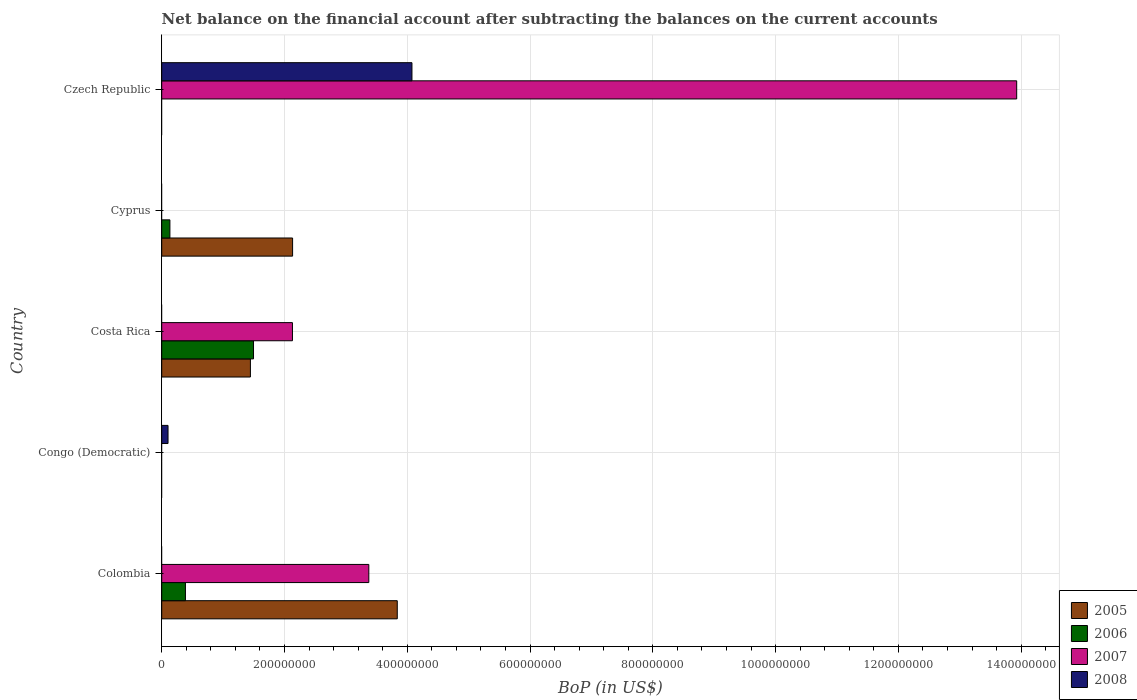Are the number of bars on each tick of the Y-axis equal?
Give a very brief answer. No. How many bars are there on the 5th tick from the top?
Provide a short and direct response. 3. How many bars are there on the 2nd tick from the bottom?
Make the answer very short. 1. In how many cases, is the number of bars for a given country not equal to the number of legend labels?
Ensure brevity in your answer.  5. Across all countries, what is the maximum Balance of Payments in 2006?
Your answer should be compact. 1.50e+08. What is the total Balance of Payments in 2007 in the graph?
Make the answer very short. 1.94e+09. What is the average Balance of Payments in 2006 per country?
Ensure brevity in your answer.  4.03e+07. What is the difference between the Balance of Payments in 2005 and Balance of Payments in 2006 in Cyprus?
Your answer should be very brief. 2.00e+08. What is the ratio of the Balance of Payments in 2005 in Costa Rica to that in Cyprus?
Keep it short and to the point. 0.68. What is the difference between the highest and the second highest Balance of Payments in 2006?
Keep it short and to the point. 1.11e+08. What is the difference between the highest and the lowest Balance of Payments in 2006?
Give a very brief answer. 1.50e+08. Is it the case that in every country, the sum of the Balance of Payments in 2008 and Balance of Payments in 2006 is greater than the sum of Balance of Payments in 2007 and Balance of Payments in 2005?
Give a very brief answer. No. Is it the case that in every country, the sum of the Balance of Payments in 2008 and Balance of Payments in 2005 is greater than the Balance of Payments in 2007?
Offer a very short reply. No. How many countries are there in the graph?
Make the answer very short. 5. What is the difference between two consecutive major ticks on the X-axis?
Make the answer very short. 2.00e+08. Does the graph contain grids?
Your answer should be compact. Yes. How many legend labels are there?
Provide a short and direct response. 4. What is the title of the graph?
Give a very brief answer. Net balance on the financial account after subtracting the balances on the current accounts. Does "1987" appear as one of the legend labels in the graph?
Your response must be concise. No. What is the label or title of the X-axis?
Make the answer very short. BoP (in US$). What is the BoP (in US$) in 2005 in Colombia?
Keep it short and to the point. 3.84e+08. What is the BoP (in US$) of 2006 in Colombia?
Your answer should be very brief. 3.87e+07. What is the BoP (in US$) of 2007 in Colombia?
Your answer should be compact. 3.37e+08. What is the BoP (in US$) of 2006 in Congo (Democratic)?
Provide a short and direct response. 0. What is the BoP (in US$) in 2007 in Congo (Democratic)?
Offer a very short reply. 0. What is the BoP (in US$) in 2008 in Congo (Democratic)?
Your answer should be compact. 1.03e+07. What is the BoP (in US$) of 2005 in Costa Rica?
Provide a short and direct response. 1.44e+08. What is the BoP (in US$) of 2006 in Costa Rica?
Provide a short and direct response. 1.50e+08. What is the BoP (in US$) of 2007 in Costa Rica?
Your answer should be compact. 2.13e+08. What is the BoP (in US$) of 2005 in Cyprus?
Provide a succinct answer. 2.13e+08. What is the BoP (in US$) in 2006 in Cyprus?
Your answer should be compact. 1.33e+07. What is the BoP (in US$) of 2007 in Cyprus?
Give a very brief answer. 0. What is the BoP (in US$) in 2006 in Czech Republic?
Your response must be concise. 0. What is the BoP (in US$) of 2007 in Czech Republic?
Keep it short and to the point. 1.39e+09. What is the BoP (in US$) of 2008 in Czech Republic?
Provide a short and direct response. 4.08e+08. Across all countries, what is the maximum BoP (in US$) of 2005?
Your answer should be compact. 3.84e+08. Across all countries, what is the maximum BoP (in US$) of 2006?
Keep it short and to the point. 1.50e+08. Across all countries, what is the maximum BoP (in US$) of 2007?
Offer a very short reply. 1.39e+09. Across all countries, what is the maximum BoP (in US$) of 2008?
Keep it short and to the point. 4.08e+08. Across all countries, what is the minimum BoP (in US$) of 2006?
Offer a terse response. 0. Across all countries, what is the minimum BoP (in US$) of 2008?
Offer a very short reply. 0. What is the total BoP (in US$) in 2005 in the graph?
Give a very brief answer. 7.41e+08. What is the total BoP (in US$) of 2006 in the graph?
Your answer should be very brief. 2.02e+08. What is the total BoP (in US$) of 2007 in the graph?
Give a very brief answer. 1.94e+09. What is the total BoP (in US$) in 2008 in the graph?
Make the answer very short. 4.18e+08. What is the difference between the BoP (in US$) in 2005 in Colombia and that in Costa Rica?
Provide a short and direct response. 2.39e+08. What is the difference between the BoP (in US$) of 2006 in Colombia and that in Costa Rica?
Your answer should be very brief. -1.11e+08. What is the difference between the BoP (in US$) of 2007 in Colombia and that in Costa Rica?
Your response must be concise. 1.24e+08. What is the difference between the BoP (in US$) of 2005 in Colombia and that in Cyprus?
Offer a very short reply. 1.70e+08. What is the difference between the BoP (in US$) in 2006 in Colombia and that in Cyprus?
Your response must be concise. 2.53e+07. What is the difference between the BoP (in US$) of 2007 in Colombia and that in Czech Republic?
Offer a terse response. -1.06e+09. What is the difference between the BoP (in US$) in 2008 in Congo (Democratic) and that in Czech Republic?
Provide a short and direct response. -3.97e+08. What is the difference between the BoP (in US$) of 2005 in Costa Rica and that in Cyprus?
Provide a succinct answer. -6.87e+07. What is the difference between the BoP (in US$) of 2006 in Costa Rica and that in Cyprus?
Provide a short and direct response. 1.36e+08. What is the difference between the BoP (in US$) of 2007 in Costa Rica and that in Czech Republic?
Provide a short and direct response. -1.18e+09. What is the difference between the BoP (in US$) in 2005 in Colombia and the BoP (in US$) in 2008 in Congo (Democratic)?
Your answer should be very brief. 3.73e+08. What is the difference between the BoP (in US$) of 2006 in Colombia and the BoP (in US$) of 2008 in Congo (Democratic)?
Offer a terse response. 2.84e+07. What is the difference between the BoP (in US$) of 2007 in Colombia and the BoP (in US$) of 2008 in Congo (Democratic)?
Offer a terse response. 3.27e+08. What is the difference between the BoP (in US$) of 2005 in Colombia and the BoP (in US$) of 2006 in Costa Rica?
Provide a succinct answer. 2.34e+08. What is the difference between the BoP (in US$) in 2005 in Colombia and the BoP (in US$) in 2007 in Costa Rica?
Give a very brief answer. 1.71e+08. What is the difference between the BoP (in US$) in 2006 in Colombia and the BoP (in US$) in 2007 in Costa Rica?
Make the answer very short. -1.74e+08. What is the difference between the BoP (in US$) of 2005 in Colombia and the BoP (in US$) of 2006 in Cyprus?
Keep it short and to the point. 3.70e+08. What is the difference between the BoP (in US$) of 2005 in Colombia and the BoP (in US$) of 2007 in Czech Republic?
Give a very brief answer. -1.01e+09. What is the difference between the BoP (in US$) in 2005 in Colombia and the BoP (in US$) in 2008 in Czech Republic?
Offer a terse response. -2.39e+07. What is the difference between the BoP (in US$) of 2006 in Colombia and the BoP (in US$) of 2007 in Czech Republic?
Give a very brief answer. -1.35e+09. What is the difference between the BoP (in US$) of 2006 in Colombia and the BoP (in US$) of 2008 in Czech Republic?
Provide a succinct answer. -3.69e+08. What is the difference between the BoP (in US$) of 2007 in Colombia and the BoP (in US$) of 2008 in Czech Republic?
Provide a short and direct response. -7.03e+07. What is the difference between the BoP (in US$) of 2005 in Costa Rica and the BoP (in US$) of 2006 in Cyprus?
Keep it short and to the point. 1.31e+08. What is the difference between the BoP (in US$) of 2005 in Costa Rica and the BoP (in US$) of 2007 in Czech Republic?
Offer a terse response. -1.25e+09. What is the difference between the BoP (in US$) in 2005 in Costa Rica and the BoP (in US$) in 2008 in Czech Republic?
Your response must be concise. -2.63e+08. What is the difference between the BoP (in US$) of 2006 in Costa Rica and the BoP (in US$) of 2007 in Czech Republic?
Your answer should be very brief. -1.24e+09. What is the difference between the BoP (in US$) in 2006 in Costa Rica and the BoP (in US$) in 2008 in Czech Republic?
Offer a terse response. -2.58e+08. What is the difference between the BoP (in US$) of 2007 in Costa Rica and the BoP (in US$) of 2008 in Czech Republic?
Provide a short and direct response. -1.95e+08. What is the difference between the BoP (in US$) of 2005 in Cyprus and the BoP (in US$) of 2007 in Czech Republic?
Offer a terse response. -1.18e+09. What is the difference between the BoP (in US$) in 2005 in Cyprus and the BoP (in US$) in 2008 in Czech Republic?
Ensure brevity in your answer.  -1.94e+08. What is the difference between the BoP (in US$) of 2006 in Cyprus and the BoP (in US$) of 2007 in Czech Republic?
Offer a very short reply. -1.38e+09. What is the difference between the BoP (in US$) of 2006 in Cyprus and the BoP (in US$) of 2008 in Czech Republic?
Your response must be concise. -3.94e+08. What is the average BoP (in US$) in 2005 per country?
Offer a terse response. 1.48e+08. What is the average BoP (in US$) of 2006 per country?
Your answer should be compact. 4.03e+07. What is the average BoP (in US$) of 2007 per country?
Provide a short and direct response. 3.89e+08. What is the average BoP (in US$) in 2008 per country?
Give a very brief answer. 8.36e+07. What is the difference between the BoP (in US$) in 2005 and BoP (in US$) in 2006 in Colombia?
Make the answer very short. 3.45e+08. What is the difference between the BoP (in US$) in 2005 and BoP (in US$) in 2007 in Colombia?
Ensure brevity in your answer.  4.63e+07. What is the difference between the BoP (in US$) in 2006 and BoP (in US$) in 2007 in Colombia?
Your answer should be compact. -2.99e+08. What is the difference between the BoP (in US$) in 2005 and BoP (in US$) in 2006 in Costa Rica?
Give a very brief answer. -5.05e+06. What is the difference between the BoP (in US$) in 2005 and BoP (in US$) in 2007 in Costa Rica?
Your response must be concise. -6.85e+07. What is the difference between the BoP (in US$) of 2006 and BoP (in US$) of 2007 in Costa Rica?
Keep it short and to the point. -6.34e+07. What is the difference between the BoP (in US$) of 2005 and BoP (in US$) of 2006 in Cyprus?
Provide a succinct answer. 2.00e+08. What is the difference between the BoP (in US$) of 2007 and BoP (in US$) of 2008 in Czech Republic?
Make the answer very short. 9.85e+08. What is the ratio of the BoP (in US$) of 2005 in Colombia to that in Costa Rica?
Offer a very short reply. 2.66. What is the ratio of the BoP (in US$) of 2006 in Colombia to that in Costa Rica?
Offer a very short reply. 0.26. What is the ratio of the BoP (in US$) of 2007 in Colombia to that in Costa Rica?
Provide a succinct answer. 1.58. What is the ratio of the BoP (in US$) in 2005 in Colombia to that in Cyprus?
Your answer should be very brief. 1.8. What is the ratio of the BoP (in US$) in 2006 in Colombia to that in Cyprus?
Offer a very short reply. 2.9. What is the ratio of the BoP (in US$) in 2007 in Colombia to that in Czech Republic?
Provide a succinct answer. 0.24. What is the ratio of the BoP (in US$) in 2008 in Congo (Democratic) to that in Czech Republic?
Keep it short and to the point. 0.03. What is the ratio of the BoP (in US$) of 2005 in Costa Rica to that in Cyprus?
Offer a terse response. 0.68. What is the ratio of the BoP (in US$) in 2006 in Costa Rica to that in Cyprus?
Ensure brevity in your answer.  11.21. What is the ratio of the BoP (in US$) in 2007 in Costa Rica to that in Czech Republic?
Offer a terse response. 0.15. What is the difference between the highest and the second highest BoP (in US$) of 2005?
Provide a succinct answer. 1.70e+08. What is the difference between the highest and the second highest BoP (in US$) in 2006?
Give a very brief answer. 1.11e+08. What is the difference between the highest and the second highest BoP (in US$) in 2007?
Offer a terse response. 1.06e+09. What is the difference between the highest and the lowest BoP (in US$) of 2005?
Provide a succinct answer. 3.84e+08. What is the difference between the highest and the lowest BoP (in US$) of 2006?
Keep it short and to the point. 1.50e+08. What is the difference between the highest and the lowest BoP (in US$) of 2007?
Your answer should be very brief. 1.39e+09. What is the difference between the highest and the lowest BoP (in US$) in 2008?
Provide a short and direct response. 4.08e+08. 